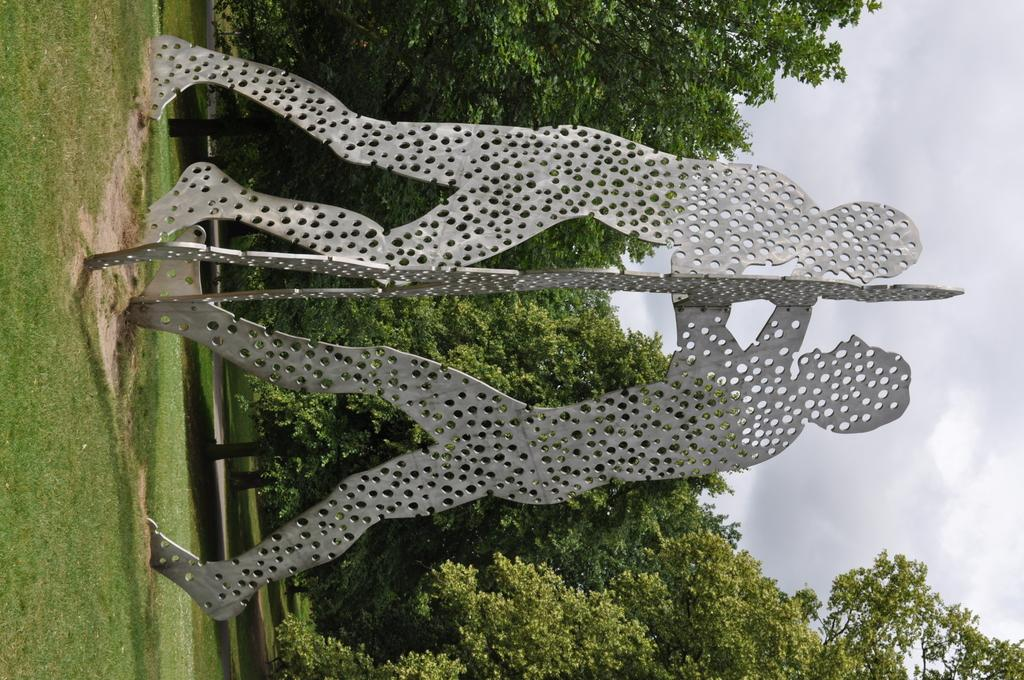What type of art is present in the image? There are sculptures in the image. Where are the sculptures located? The sculptures are on the grass. What can be seen in the background of the image? There are trees in the background of the image. How many cats are sitting on the sculptures in the image? There are no cats present in the image; it only features sculptures on the grass with trees in the background. 